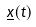<formula> <loc_0><loc_0><loc_500><loc_500>\underline { x } ( t )</formula> 